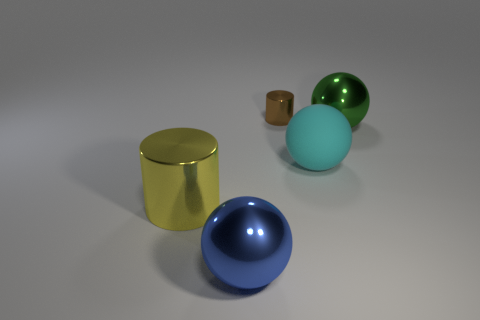Add 5 large blue metal objects. How many objects exist? 10 Subtract all cylinders. How many objects are left? 3 Add 2 big cyan matte objects. How many big cyan matte objects are left? 3 Add 2 tiny rubber things. How many tiny rubber things exist? 2 Subtract 1 yellow cylinders. How many objects are left? 4 Subtract all big brown metal blocks. Subtract all big metallic balls. How many objects are left? 3 